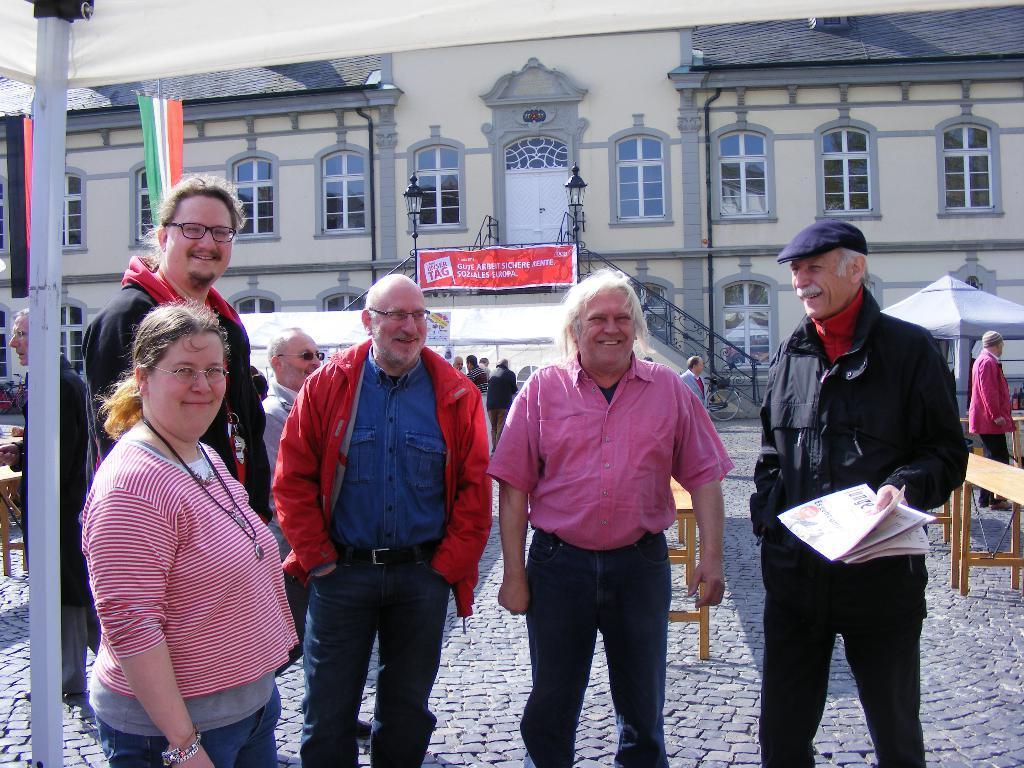Could you give a brief overview of what you see in this image? In the picture we can see four men and a woman standing and smiling, the men are wearing a jacket and shirts and trousers and one man is holding a newspaper and wearing a cap, which is blue in color and in the background, we can see a house building with windows and railing and some lamps to it, and we can also see some people are walking on the path. 